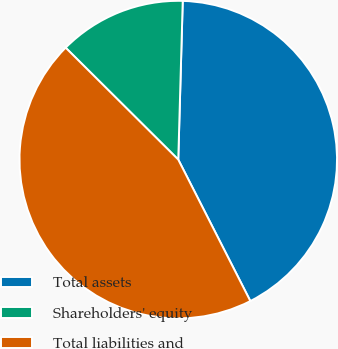<chart> <loc_0><loc_0><loc_500><loc_500><pie_chart><fcel>Total assets<fcel>Shareholders' equity<fcel>Total liabilities and<nl><fcel>42.05%<fcel>13.0%<fcel>44.95%<nl></chart> 